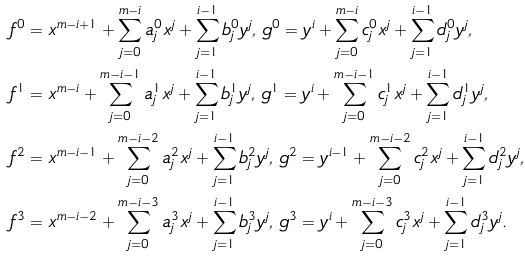Convert formula to latex. <formula><loc_0><loc_0><loc_500><loc_500>& f ^ { 0 } = x ^ { m - i + 1 } + \sum ^ { m - i } _ { j = 0 } a _ { j } ^ { 0 } x ^ { j } + \sum ^ { i - 1 } _ { j = 1 } b _ { j } ^ { 0 } y ^ { j } , \, g ^ { 0 } = y ^ { i } + \sum ^ { m - i } _ { j = 0 } c _ { j } ^ { 0 } x ^ { j } + \sum ^ { i - 1 } _ { j = 1 } d _ { j } ^ { 0 } y ^ { j } , \\ & f ^ { 1 } = x ^ { m - i } + \sum ^ { m - i - 1 } _ { j = 0 } a _ { j } ^ { 1 } x ^ { j } + \sum ^ { i - 1 } _ { j = 1 } b _ { j } ^ { 1 } y ^ { j } , \, g ^ { 1 } = y ^ { i } + \sum ^ { m - i - 1 } _ { j = 0 } c _ { j } ^ { 1 } x ^ { j } + \sum ^ { i - 1 } _ { j = 1 } d _ { j } ^ { 1 } y ^ { j } , \\ & f ^ { 2 } = x ^ { m - i - 1 } + \sum ^ { m - i - 2 } _ { j = 0 } a _ { j } ^ { 2 } x ^ { j } + \sum ^ { i - 1 } _ { j = 1 } b _ { j } ^ { 2 } y ^ { j } , \, g ^ { 2 } = y ^ { i - 1 } + \sum ^ { m - i - 2 } _ { j = 0 } c _ { j } ^ { 2 } x ^ { j } + \sum ^ { i - 1 } _ { j = 1 } d _ { j } ^ { 2 } y ^ { j } , \\ & f ^ { 3 } = x ^ { m - i - 2 } + \sum ^ { m - i - 3 } _ { j = 0 } a _ { j } ^ { 3 } x ^ { j } + \sum ^ { i - 1 } _ { j = 1 } b _ { j } ^ { 3 } y ^ { j } , \, g ^ { 3 } = y ^ { i } + \sum ^ { m - i - 3 } _ { j = 0 } c _ { j } ^ { 3 } x ^ { j } + \sum ^ { i - 1 } _ { j = 1 } d _ { j } ^ { 3 } y ^ { j } . \\</formula> 